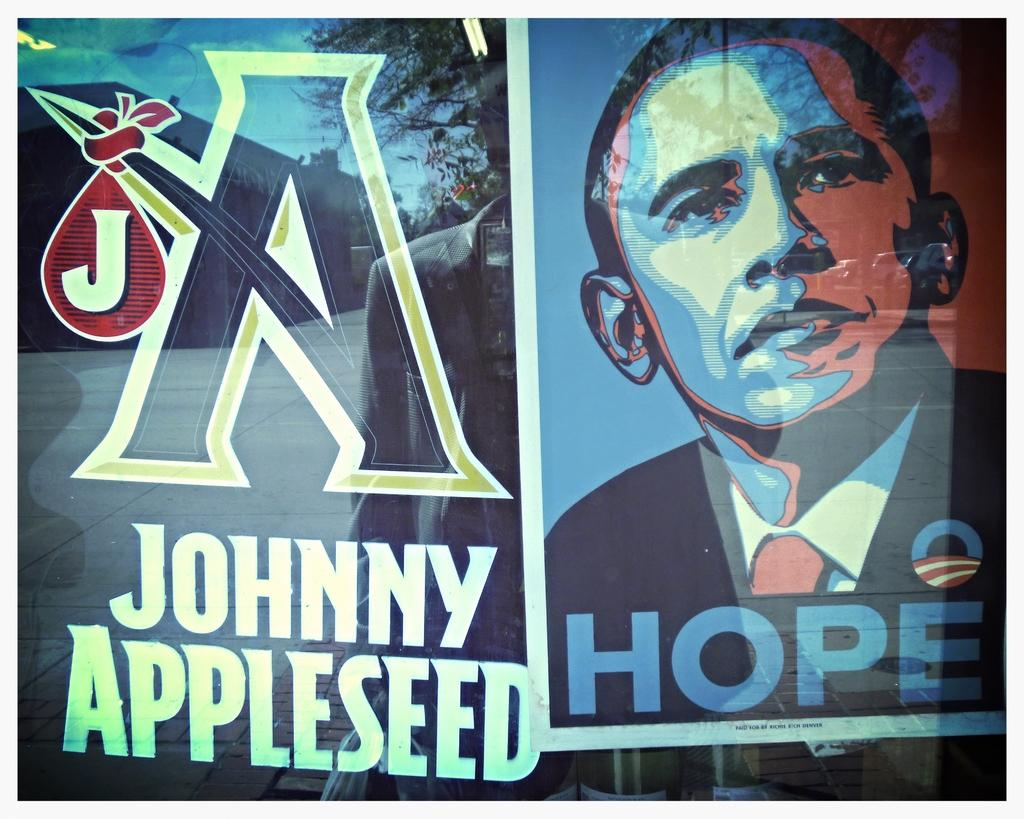<image>
Give a short and clear explanation of the subsequent image. A poster of the former president and says Johnny Appleseed in white bold font. 